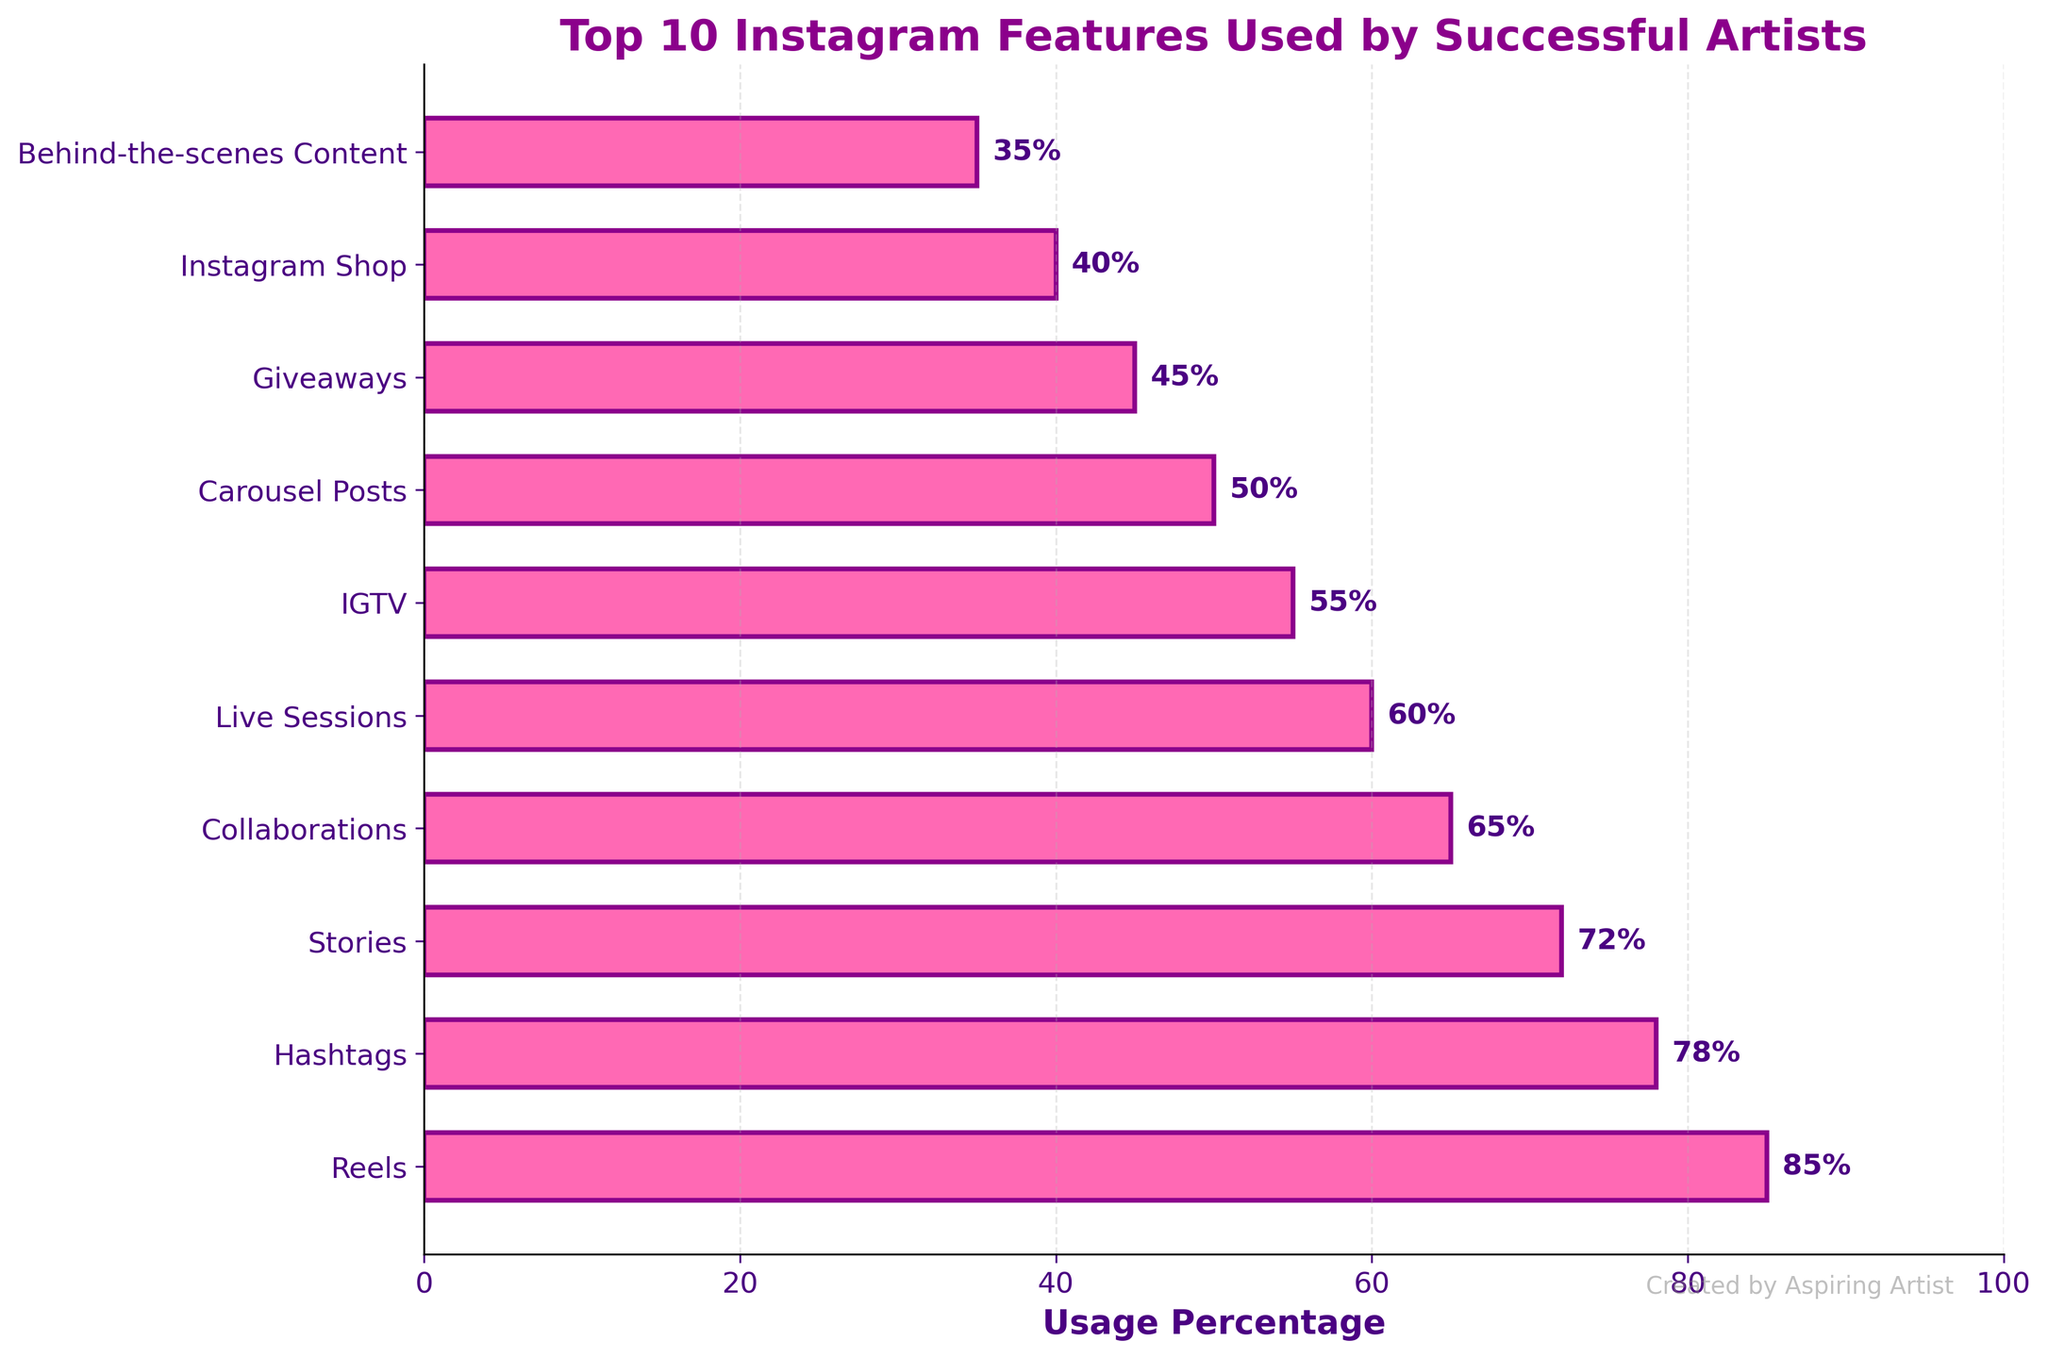Which feature is used the most by successful artists? The bar with the longest length represents the feature used most frequently. The "Reels" bar is the longest.
Answer: Reels Are Hashtags used more or less than Live Sessions? Compare the lengths of the bars for Hashtags and Live Sessions. The Hashtags bar is longer than the Live Sessions bar.
Answer: More What percentage of successful artists use collaborations? Find the bar labeled "Collaborations" and look at its corresponding percentage label.
Answer: 65% Which feature ranks 5th in usage percentage among successful artists? Count the bars from the top to the 5th position. The bar in the 5th position is "Live Sessions."
Answer: Live Sessions What is the total usage percentage for the top 3 features? Sum the percentages of the top 3 features: Reels (85) + Hashtags (78) + Stories (72). 85 + 78 + 72 = 235
Answer: 235% Which feature is just as likely to be used as Giveaways but more likely than Instagram Shop? Identify the bar with a percentage close to Giveaways (45%) but higher than Instagram Shop (40%). "Carousel Posts" has a 50% usage.
Answer: Carousel Posts What is the difference in usage percentage between Stories and Giveaways? Subtract the percentage for Giveaways from the percentage for Stories: 72 - 45 = 27
Answer: 27% What is the average usage percentage for Behind-the-scenes Content, IGTV, and Collaborations? Sum the percentages and divide by the number of features: (35 + 55 + 65) / 3 = 155 / 3 ≈ 51.67
Answer: ~51.67% How many more successful artists use Carousels compared to Instagram Shop? Subtract the percentage of Instagram Shop from Carousel Posts: 50 - 40 = 10
Answer: 10 